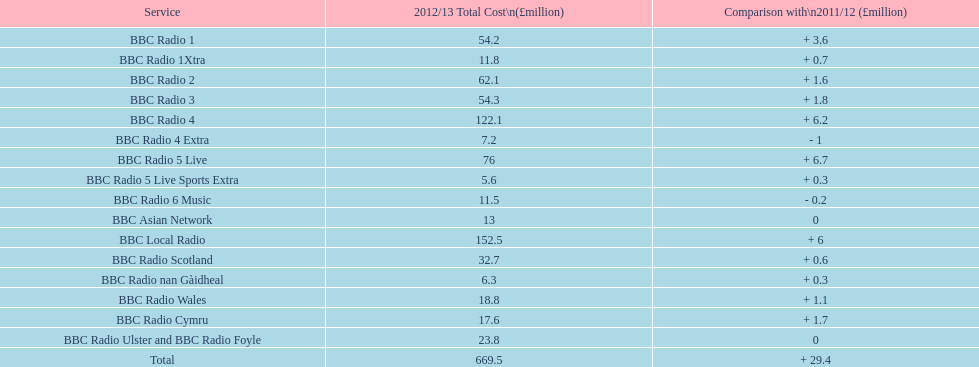During 2012/13, which bbc station incurred the greatest running costs? BBC Local Radio. Would you be able to parse every entry in this table? {'header': ['Service', '2012/13 Total Cost\\n(£million)', 'Comparison with\\n2011/12 (£million)'], 'rows': [['BBC Radio 1', '54.2', '+ 3.6'], ['BBC Radio 1Xtra', '11.8', '+ 0.7'], ['BBC Radio 2', '62.1', '+ 1.6'], ['BBC Radio 3', '54.3', '+ 1.8'], ['BBC Radio 4', '122.1', '+ 6.2'], ['BBC Radio 4 Extra', '7.2', '- 1'], ['BBC Radio 5 Live', '76', '+ 6.7'], ['BBC Radio 5 Live Sports Extra', '5.6', '+ 0.3'], ['BBC Radio 6 Music', '11.5', '- 0.2'], ['BBC Asian Network', '13', '0'], ['BBC Local Radio', '152.5', '+ 6'], ['BBC Radio Scotland', '32.7', '+ 0.6'], ['BBC Radio nan Gàidheal', '6.3', '+ 0.3'], ['BBC Radio Wales', '18.8', '+ 1.1'], ['BBC Radio Cymru', '17.6', '+ 1.7'], ['BBC Radio Ulster and BBC Radio Foyle', '23.8', '0'], ['Total', '669.5', '+ 29.4']]} 